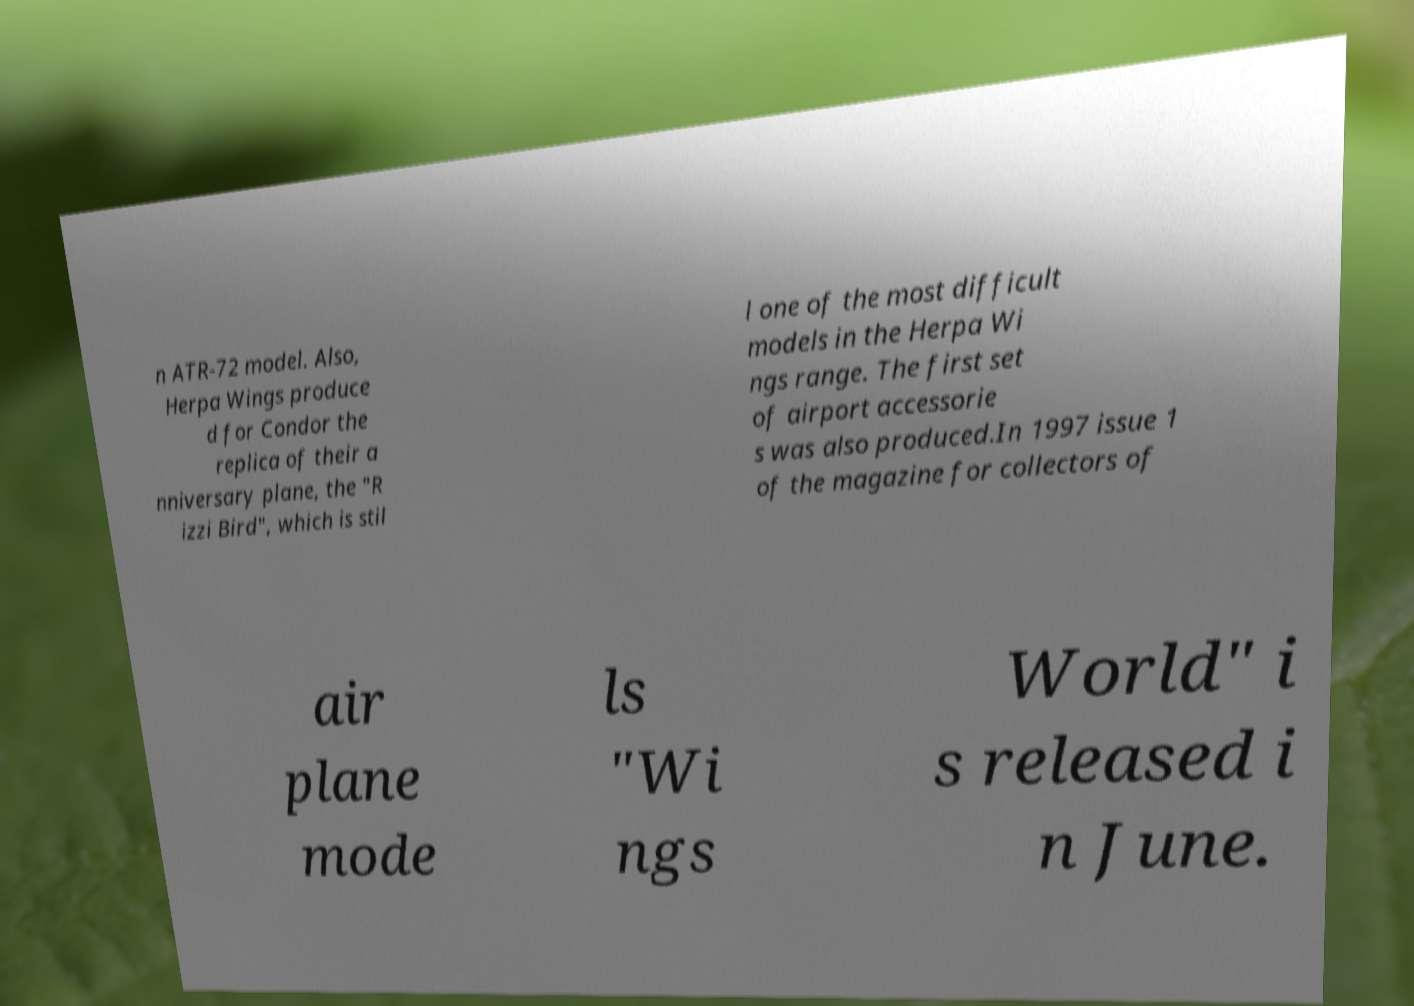Please read and relay the text visible in this image. What does it say? n ATR-72 model. Also, Herpa Wings produce d for Condor the replica of their a nniversary plane, the "R izzi Bird", which is stil l one of the most difficult models in the Herpa Wi ngs range. The first set of airport accessorie s was also produced.In 1997 issue 1 of the magazine for collectors of air plane mode ls "Wi ngs World" i s released i n June. 